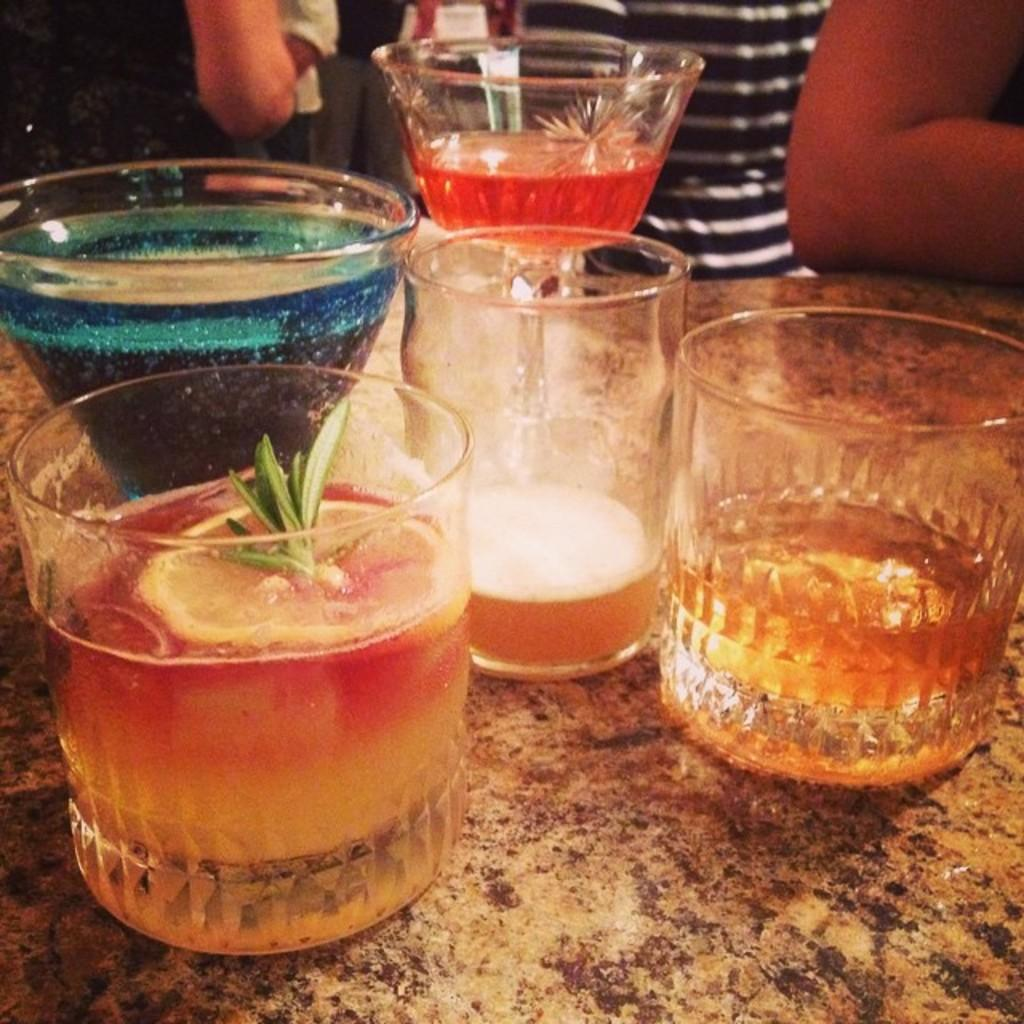What is located in the foreground of the picture? There is a table in the foreground of the picture. What can be seen on the table? There are glasses with different drinks on the table. Are there any people visible in the image? Yes, there are people visible at the top of the image. What type of pie is being shared among the people at the top of the image? There is no pie present in the image; only glasses with different drinks are visible on the table. 